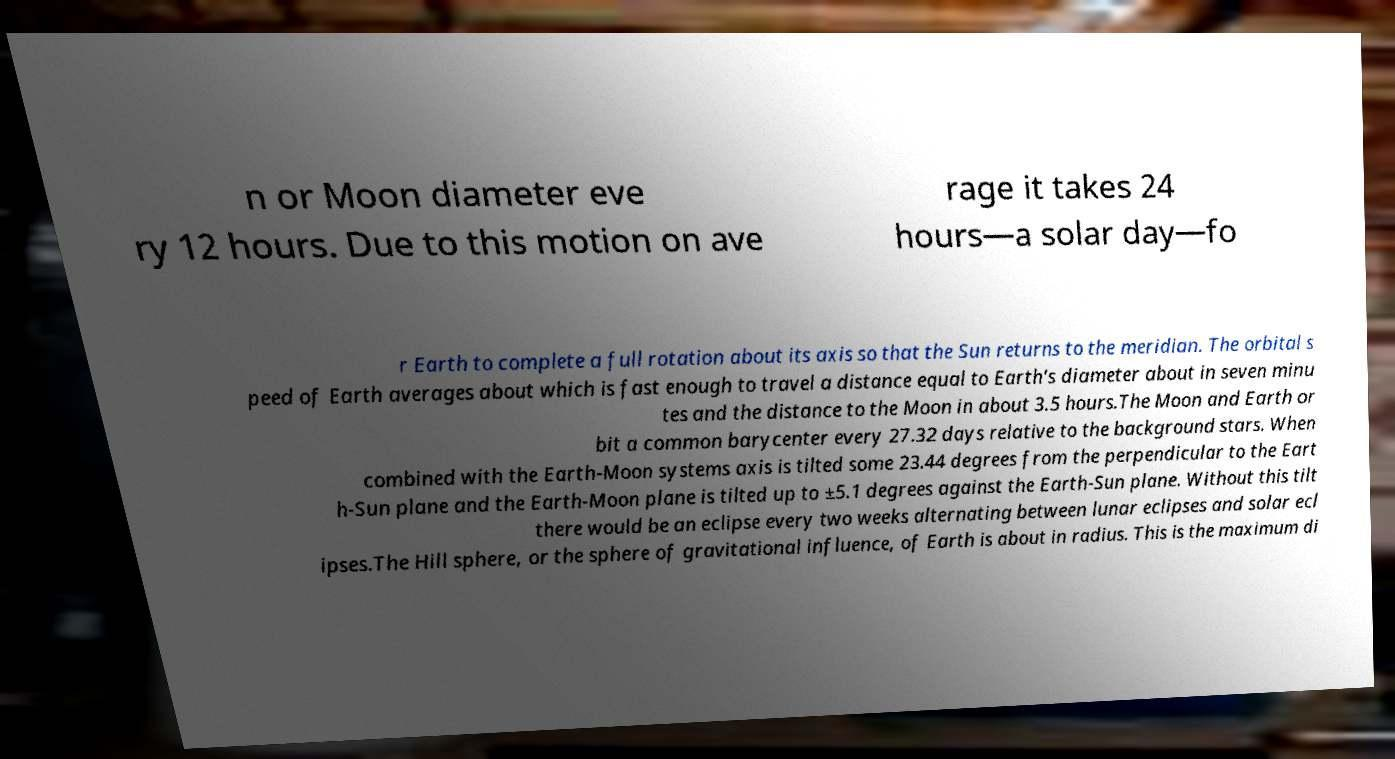Please read and relay the text visible in this image. What does it say? n or Moon diameter eve ry 12 hours. Due to this motion on ave rage it takes 24 hours—a solar day—fo r Earth to complete a full rotation about its axis so that the Sun returns to the meridian. The orbital s peed of Earth averages about which is fast enough to travel a distance equal to Earth's diameter about in seven minu tes and the distance to the Moon in about 3.5 hours.The Moon and Earth or bit a common barycenter every 27.32 days relative to the background stars. When combined with the Earth-Moon systems axis is tilted some 23.44 degrees from the perpendicular to the Eart h-Sun plane and the Earth-Moon plane is tilted up to ±5.1 degrees against the Earth-Sun plane. Without this tilt there would be an eclipse every two weeks alternating between lunar eclipses and solar ecl ipses.The Hill sphere, or the sphere of gravitational influence, of Earth is about in radius. This is the maximum di 